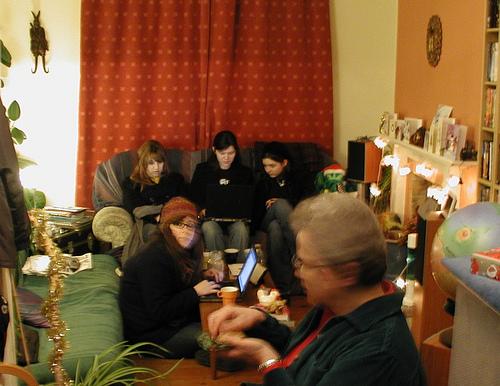How many people are in this photo?
Be succinct. 5. What is the glowing object in the center of this picture?
Keep it brief. Laptop. Is the woman young?
Write a very short answer. Yes. 